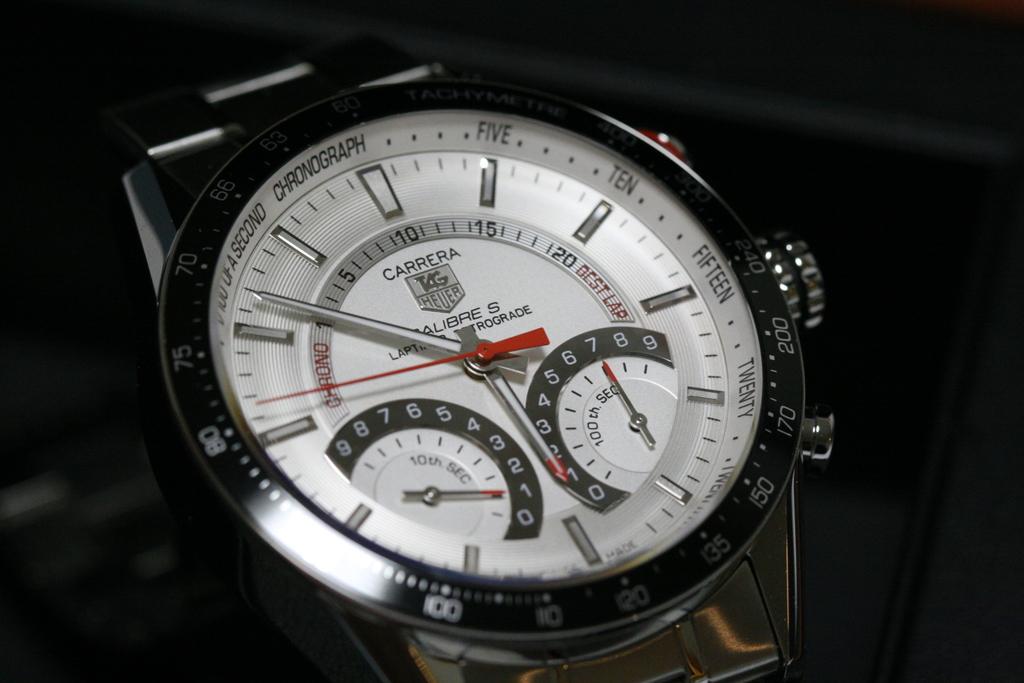Is the watch a carrerra?
Ensure brevity in your answer.  Yes. What word is next to  the word second at the top of the watch?
Your answer should be very brief. Chronograph. 